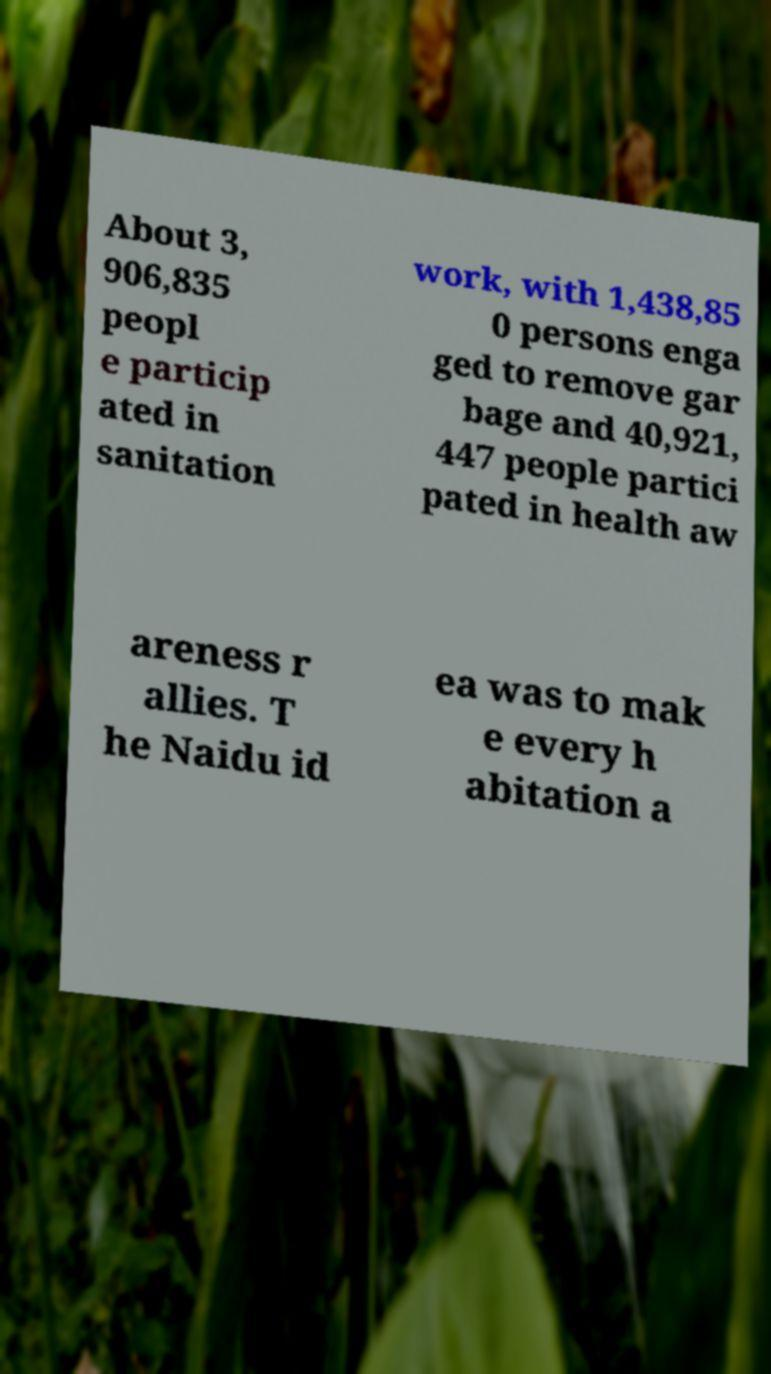Please read and relay the text visible in this image. What does it say? About 3, 906,835 peopl e particip ated in sanitation work, with 1,438,85 0 persons enga ged to remove gar bage and 40,921, 447 people partici pated in health aw areness r allies. T he Naidu id ea was to mak e every h abitation a 